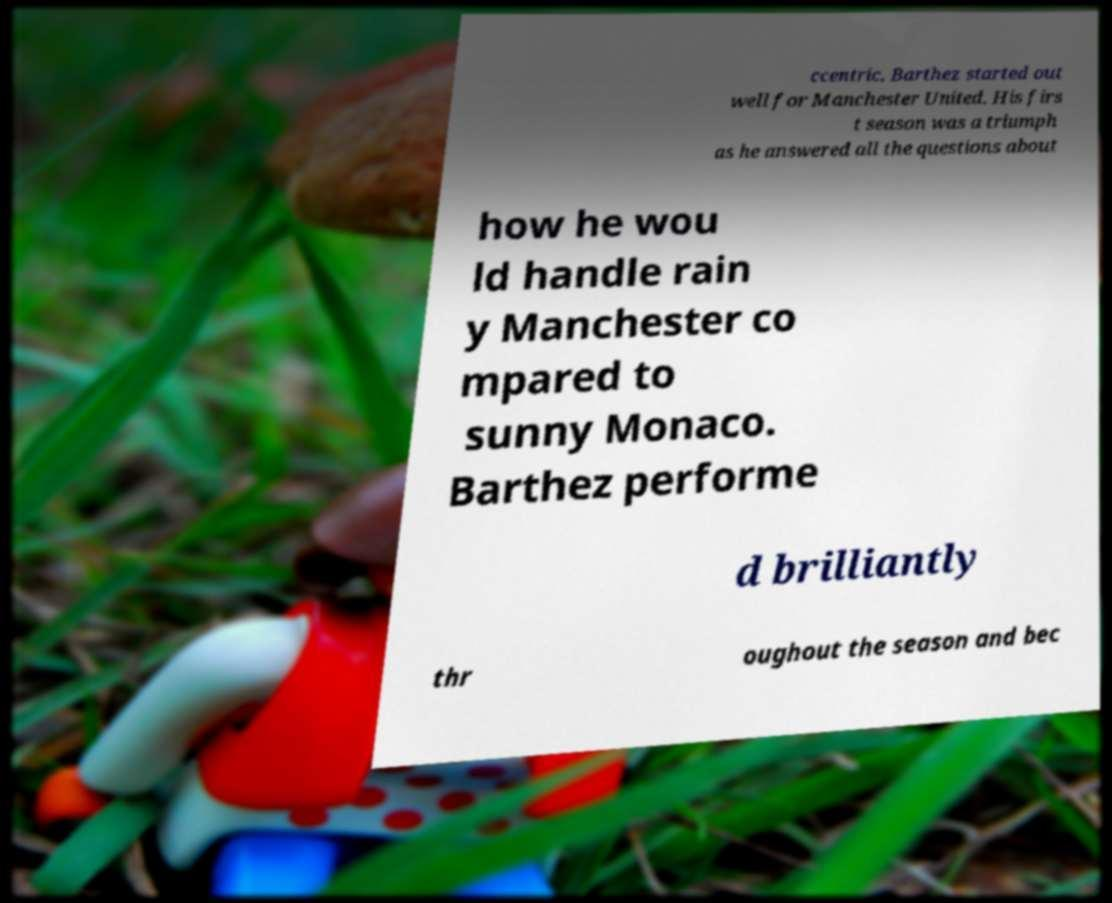What messages or text are displayed in this image? I need them in a readable, typed format. ccentric, Barthez started out well for Manchester United. His firs t season was a triumph as he answered all the questions about how he wou ld handle rain y Manchester co mpared to sunny Monaco. Barthez performe d brilliantly thr oughout the season and bec 